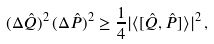Convert formula to latex. <formula><loc_0><loc_0><loc_500><loc_500>( \Delta \hat { Q } ) ^ { 2 } \, ( \Delta \hat { P } ) ^ { 2 } \geq \frac { 1 } { 4 } | \langle [ \hat { Q } , \hat { P } ] \rangle | ^ { 2 } \, ,</formula> 